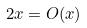<formula> <loc_0><loc_0><loc_500><loc_500>2 x = O ( x )</formula> 